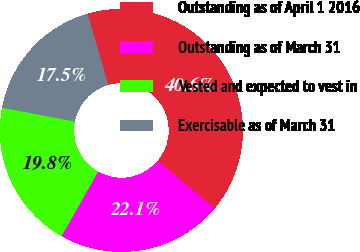Convert chart. <chart><loc_0><loc_0><loc_500><loc_500><pie_chart><fcel>Outstanding as of April 1 2016<fcel>Outstanding as of March 31<fcel>Vested and expected to vest in<fcel>Exercisable as of March 31<nl><fcel>40.58%<fcel>22.11%<fcel>19.81%<fcel>17.5%<nl></chart> 